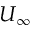Convert formula to latex. <formula><loc_0><loc_0><loc_500><loc_500>U _ { \infty }</formula> 